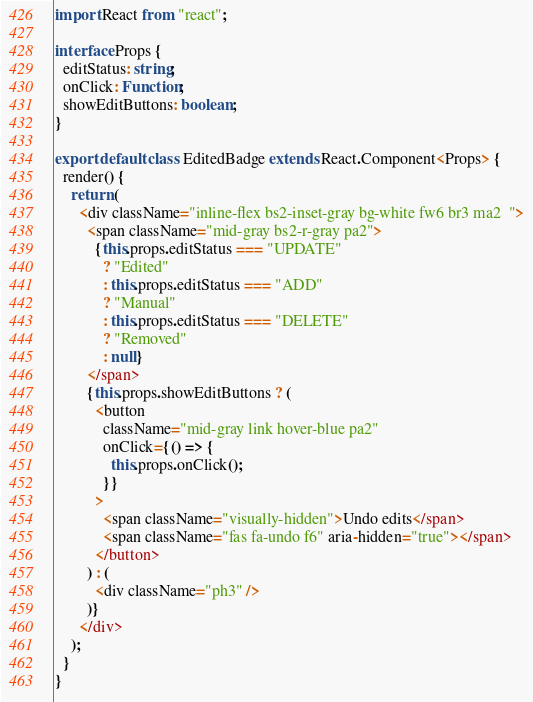Convert code to text. <code><loc_0><loc_0><loc_500><loc_500><_TypeScript_>import React from "react";

interface Props {
  editStatus: string;
  onClick: Function;
  showEditButtons: boolean;
}

export default class EditedBadge extends React.Component<Props> {
  render() {
    return (
      <div className="inline-flex bs2-inset-gray bg-white fw6 br3 ma2  ">
        <span className="mid-gray bs2-r-gray pa2">
          {this.props.editStatus === "UPDATE"
            ? "Edited"
            : this.props.editStatus === "ADD"
            ? "Manual"
            : this.props.editStatus === "DELETE"
            ? "Removed"
            : null}
        </span>
        {this.props.showEditButtons ? (
          <button
            className="mid-gray link hover-blue pa2"
            onClick={() => {
              this.props.onClick();
            }}
          >
            <span className="visually-hidden">Undo edits</span>
            <span className="fas fa-undo f6" aria-hidden="true"></span>
          </button>
        ) : (
          <div className="ph3" />
        )}
      </div>
    );
  }
}
</code> 